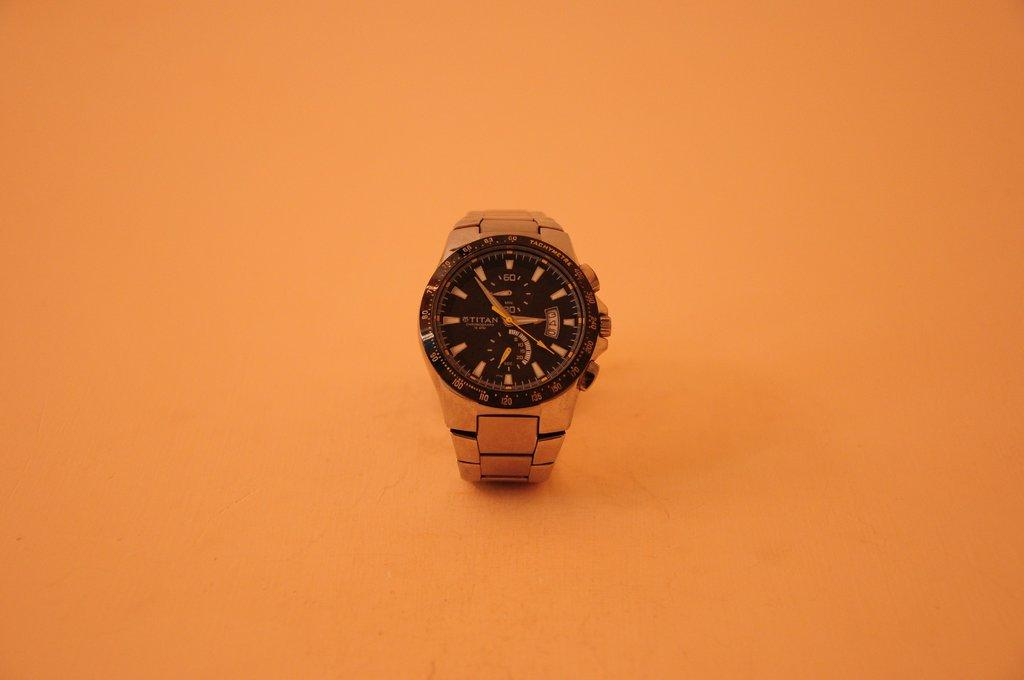<image>
Relay a brief, clear account of the picture shown. A Titan wristwatch with a gold band and a black face. 